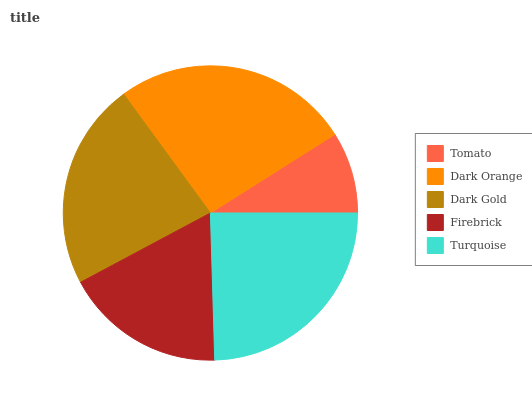Is Tomato the minimum?
Answer yes or no. Yes. Is Dark Orange the maximum?
Answer yes or no. Yes. Is Dark Gold the minimum?
Answer yes or no. No. Is Dark Gold the maximum?
Answer yes or no. No. Is Dark Orange greater than Dark Gold?
Answer yes or no. Yes. Is Dark Gold less than Dark Orange?
Answer yes or no. Yes. Is Dark Gold greater than Dark Orange?
Answer yes or no. No. Is Dark Orange less than Dark Gold?
Answer yes or no. No. Is Dark Gold the high median?
Answer yes or no. Yes. Is Dark Gold the low median?
Answer yes or no. Yes. Is Firebrick the high median?
Answer yes or no. No. Is Tomato the low median?
Answer yes or no. No. 